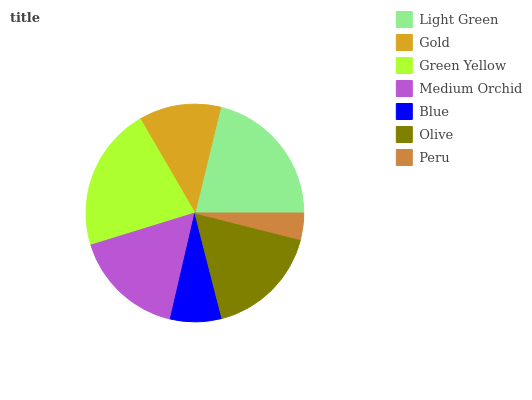Is Peru the minimum?
Answer yes or no. Yes. Is Green Yellow the maximum?
Answer yes or no. Yes. Is Gold the minimum?
Answer yes or no. No. Is Gold the maximum?
Answer yes or no. No. Is Light Green greater than Gold?
Answer yes or no. Yes. Is Gold less than Light Green?
Answer yes or no. Yes. Is Gold greater than Light Green?
Answer yes or no. No. Is Light Green less than Gold?
Answer yes or no. No. Is Medium Orchid the high median?
Answer yes or no. Yes. Is Medium Orchid the low median?
Answer yes or no. Yes. Is Olive the high median?
Answer yes or no. No. Is Blue the low median?
Answer yes or no. No. 